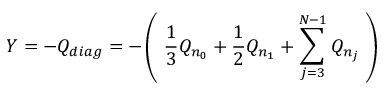<formula> <loc_0><loc_0><loc_500><loc_500>Y = - Q _ { d i a g } = - \left ( \, \frac { 1 } { 3 } Q _ { n _ { 0 } } + \frac { 1 } { 2 } Q _ { n _ { 1 } } + \sum _ { j = 3 } ^ { N - 1 } Q _ { n _ { j } } \, \right )</formula> 